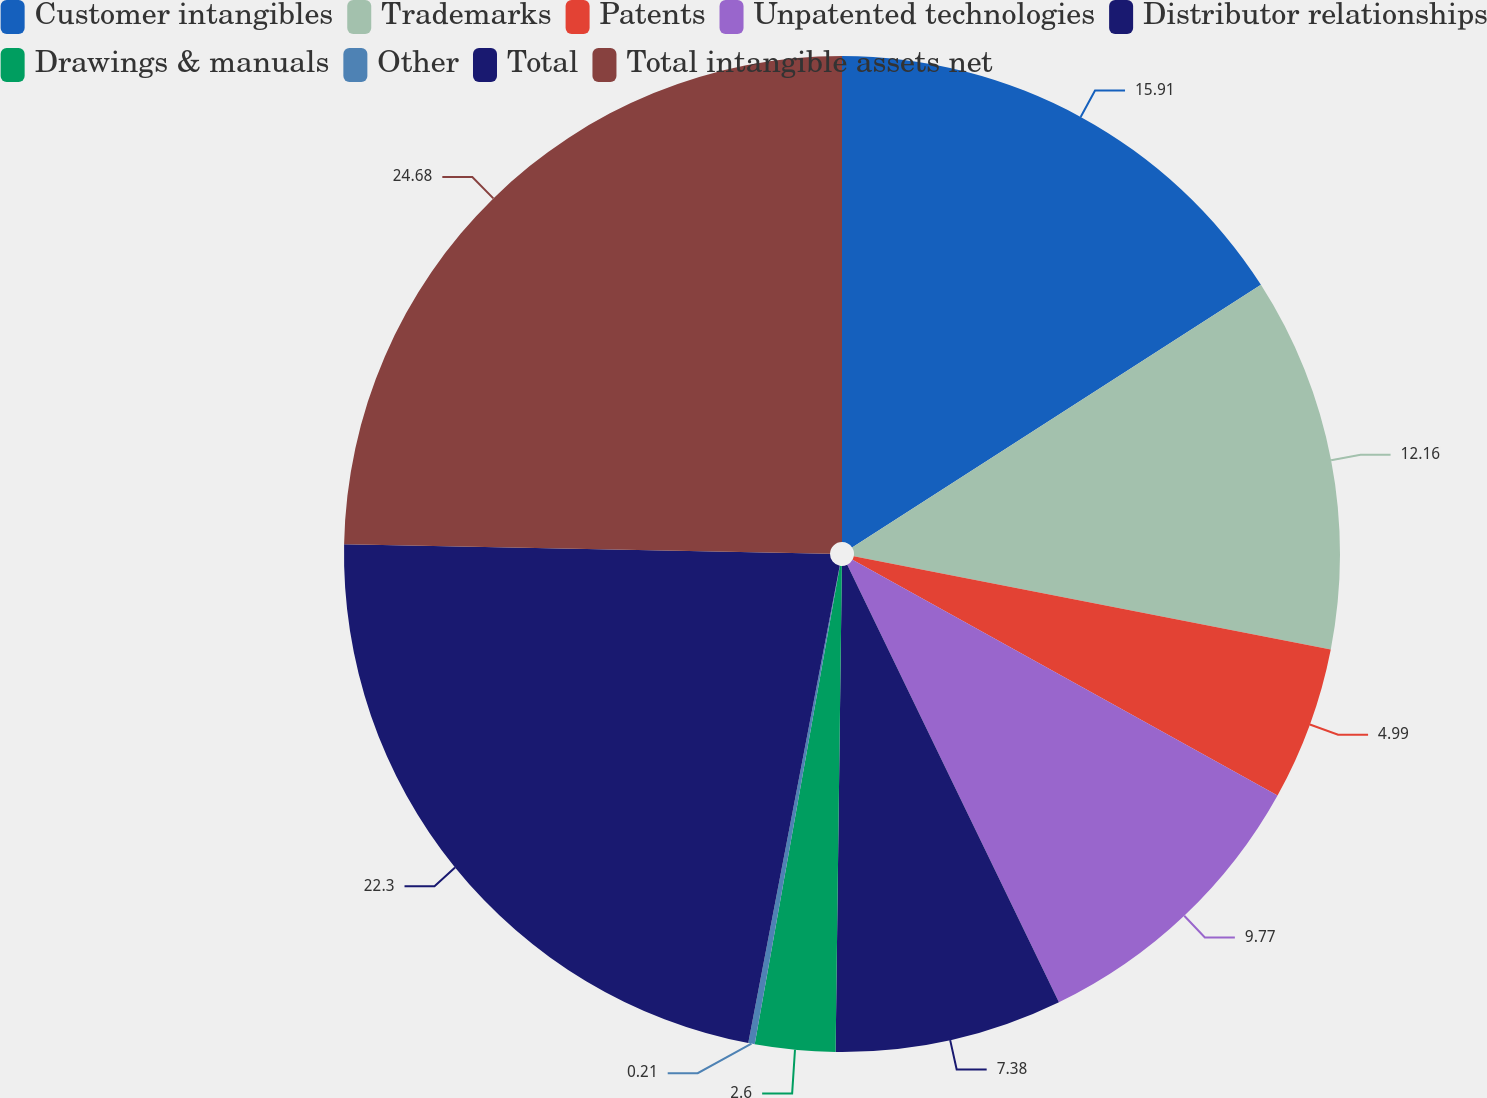Convert chart to OTSL. <chart><loc_0><loc_0><loc_500><loc_500><pie_chart><fcel>Customer intangibles<fcel>Trademarks<fcel>Patents<fcel>Unpatented technologies<fcel>Distributor relationships<fcel>Drawings & manuals<fcel>Other<fcel>Total<fcel>Total intangible assets net<nl><fcel>15.91%<fcel>12.16%<fcel>4.99%<fcel>9.77%<fcel>7.38%<fcel>2.6%<fcel>0.21%<fcel>22.3%<fcel>24.69%<nl></chart> 